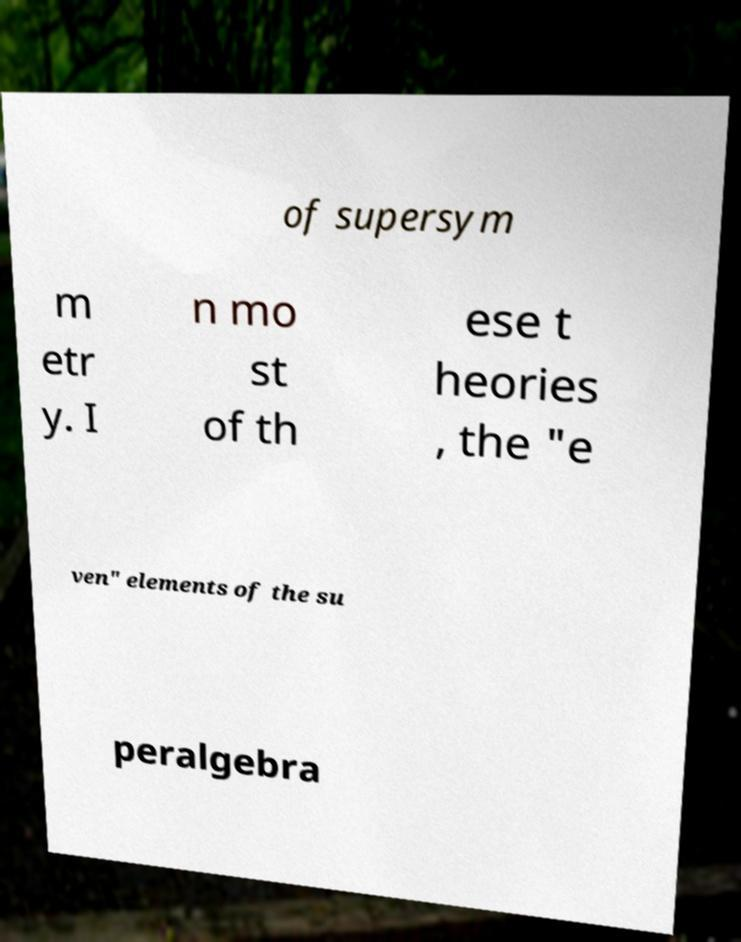Please read and relay the text visible in this image. What does it say? of supersym m etr y. I n mo st of th ese t heories , the "e ven" elements of the su peralgebra 